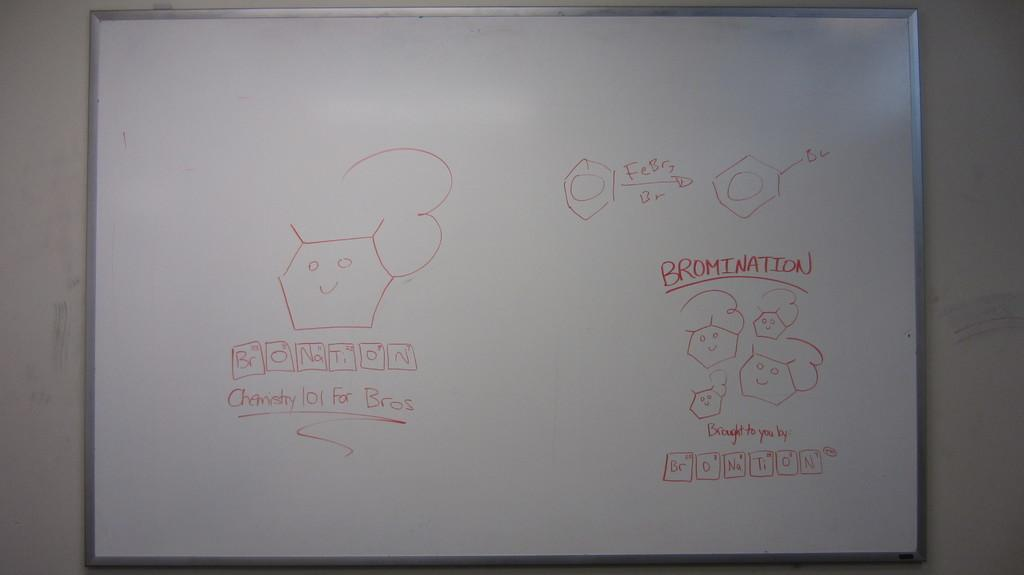<image>
Describe the image concisely. Someone has written Bromination on the whiteboard in red marker. 